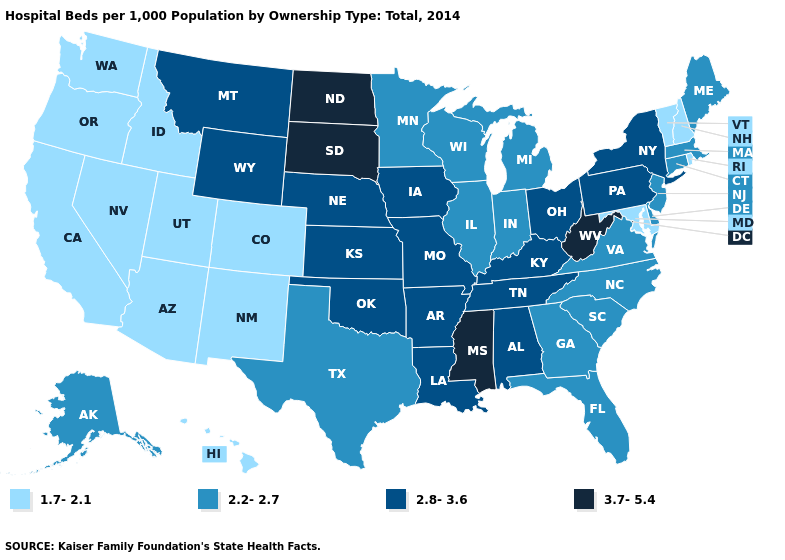How many symbols are there in the legend?
Quick response, please. 4. Which states have the highest value in the USA?
Write a very short answer. Mississippi, North Dakota, South Dakota, West Virginia. Does Tennessee have the lowest value in the South?
Short answer required. No. Does Florida have a lower value than Kansas?
Concise answer only. Yes. What is the lowest value in the West?
Write a very short answer. 1.7-2.1. Name the states that have a value in the range 1.7-2.1?
Write a very short answer. Arizona, California, Colorado, Hawaii, Idaho, Maryland, Nevada, New Hampshire, New Mexico, Oregon, Rhode Island, Utah, Vermont, Washington. Does Massachusetts have the same value as Arkansas?
Concise answer only. No. Name the states that have a value in the range 2.8-3.6?
Keep it brief. Alabama, Arkansas, Iowa, Kansas, Kentucky, Louisiana, Missouri, Montana, Nebraska, New York, Ohio, Oklahoma, Pennsylvania, Tennessee, Wyoming. What is the value of Kentucky?
Keep it brief. 2.8-3.6. What is the highest value in states that border Louisiana?
Answer briefly. 3.7-5.4. Among the states that border Illinois , which have the highest value?
Give a very brief answer. Iowa, Kentucky, Missouri. How many symbols are there in the legend?
Give a very brief answer. 4. What is the value of Maryland?
Answer briefly. 1.7-2.1. What is the value of Iowa?
Concise answer only. 2.8-3.6. 